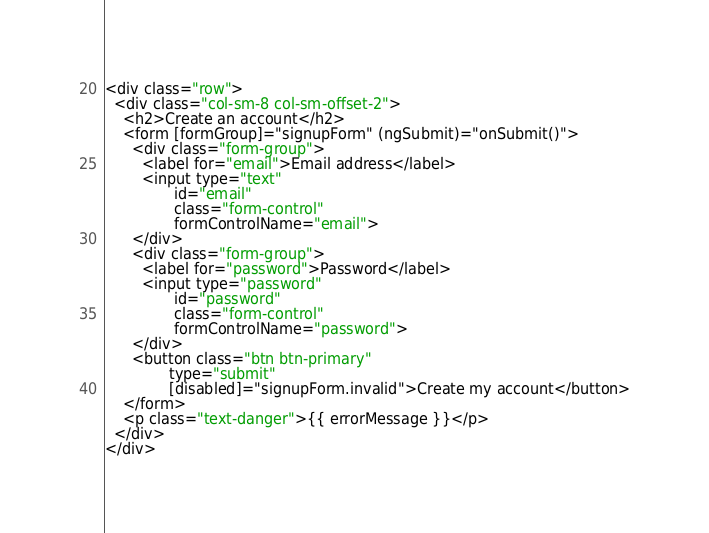Convert code to text. <code><loc_0><loc_0><loc_500><loc_500><_HTML_><div class="row">
  <div class="col-sm-8 col-sm-offset-2">
    <h2>Create an account</h2>
    <form [formGroup]="signupForm" (ngSubmit)="onSubmit()">
      <div class="form-group">
        <label for="email">Email address</label>
        <input type="text"
               id="email"
               class="form-control"
               formControlName="email">
      </div>
      <div class="form-group">
        <label for="password">Password</label>
        <input type="password"
               id="password"
               class="form-control"
               formControlName="password">
      </div>
      <button class="btn btn-primary"
              type="submit"
              [disabled]="signupForm.invalid">Create my account</button>
    </form>
    <p class="text-danger">{{ errorMessage }}</p>
  </div>
</div></code> 